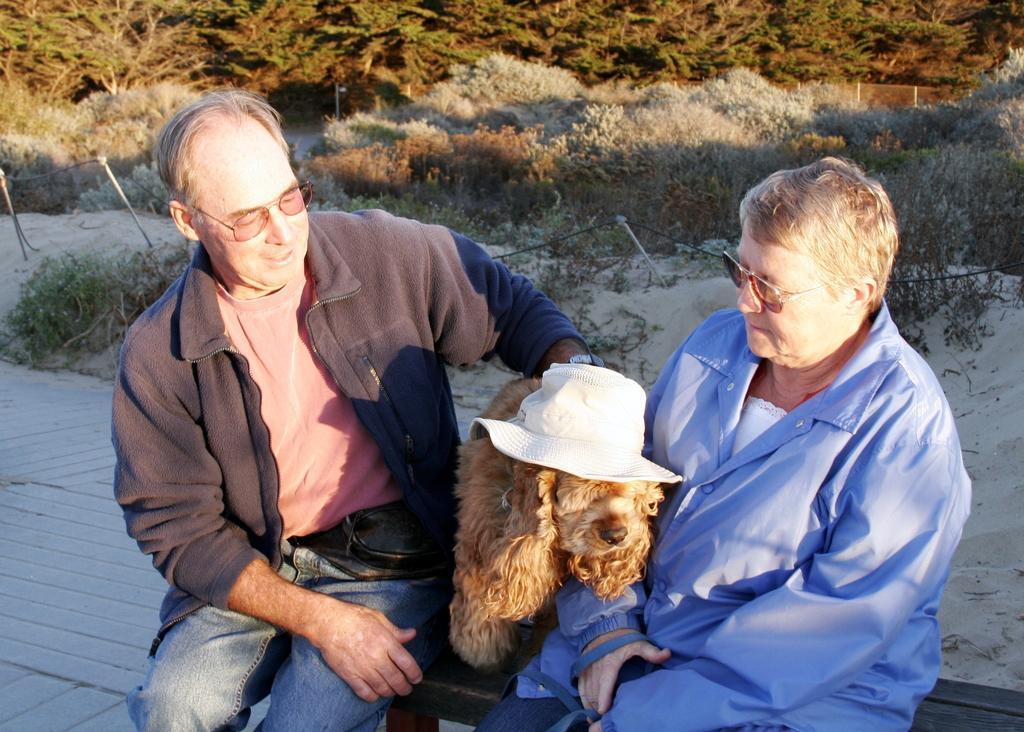How would you summarize this image in a sentence or two? On the right most, we see women wearing blue jacket and blue jeans. She is catching the rope of a dog and she is looking at that dog. To the right of her, we see a dog which is brown in color wearing white color hat. On the left most, we see a man wearing pink color t-shirt with blue jacket and blue jeans. He is also wearing goggles and looking at the dog. He is even wearing a watch. Behind them, we see trees, shrubs and also a sand. On the leftmost, we see two poles which is fitted on that sand. 